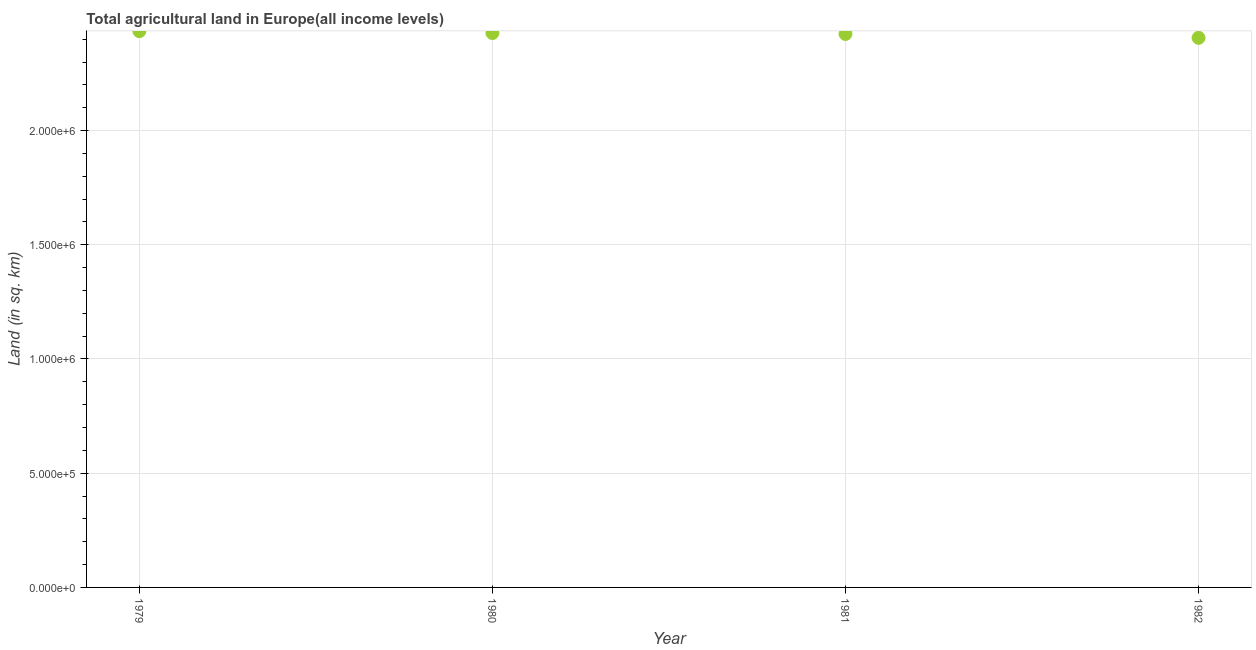What is the agricultural land in 1980?
Offer a very short reply. 2.43e+06. Across all years, what is the maximum agricultural land?
Provide a short and direct response. 2.44e+06. Across all years, what is the minimum agricultural land?
Your answer should be compact. 2.41e+06. In which year was the agricultural land maximum?
Your answer should be compact. 1979. What is the sum of the agricultural land?
Your answer should be compact. 9.69e+06. What is the difference between the agricultural land in 1981 and 1982?
Your response must be concise. 1.69e+04. What is the average agricultural land per year?
Provide a short and direct response. 2.42e+06. What is the median agricultural land?
Keep it short and to the point. 2.42e+06. In how many years, is the agricultural land greater than 1700000 sq. km?
Provide a succinct answer. 4. What is the ratio of the agricultural land in 1980 to that in 1981?
Your response must be concise. 1. Is the agricultural land in 1980 less than that in 1982?
Your answer should be very brief. No. What is the difference between the highest and the second highest agricultural land?
Offer a terse response. 8198. What is the difference between the highest and the lowest agricultural land?
Offer a very short reply. 2.92e+04. How many dotlines are there?
Offer a terse response. 1. Are the values on the major ticks of Y-axis written in scientific E-notation?
Give a very brief answer. Yes. Does the graph contain any zero values?
Ensure brevity in your answer.  No. Does the graph contain grids?
Offer a very short reply. Yes. What is the title of the graph?
Offer a very short reply. Total agricultural land in Europe(all income levels). What is the label or title of the X-axis?
Provide a succinct answer. Year. What is the label or title of the Y-axis?
Provide a short and direct response. Land (in sq. km). What is the Land (in sq. km) in 1979?
Ensure brevity in your answer.  2.44e+06. What is the Land (in sq. km) in 1980?
Provide a short and direct response. 2.43e+06. What is the Land (in sq. km) in 1981?
Your response must be concise. 2.42e+06. What is the Land (in sq. km) in 1982?
Keep it short and to the point. 2.41e+06. What is the difference between the Land (in sq. km) in 1979 and 1980?
Offer a very short reply. 8198. What is the difference between the Land (in sq. km) in 1979 and 1981?
Provide a succinct answer. 1.23e+04. What is the difference between the Land (in sq. km) in 1979 and 1982?
Provide a short and direct response. 2.92e+04. What is the difference between the Land (in sq. km) in 1980 and 1981?
Keep it short and to the point. 4124. What is the difference between the Land (in sq. km) in 1980 and 1982?
Give a very brief answer. 2.10e+04. What is the difference between the Land (in sq. km) in 1981 and 1982?
Give a very brief answer. 1.69e+04. What is the ratio of the Land (in sq. km) in 1979 to that in 1980?
Your response must be concise. 1. What is the ratio of the Land (in sq. km) in 1979 to that in 1981?
Offer a terse response. 1. What is the ratio of the Land (in sq. km) in 1979 to that in 1982?
Ensure brevity in your answer.  1.01. What is the ratio of the Land (in sq. km) in 1980 to that in 1982?
Keep it short and to the point. 1.01. 